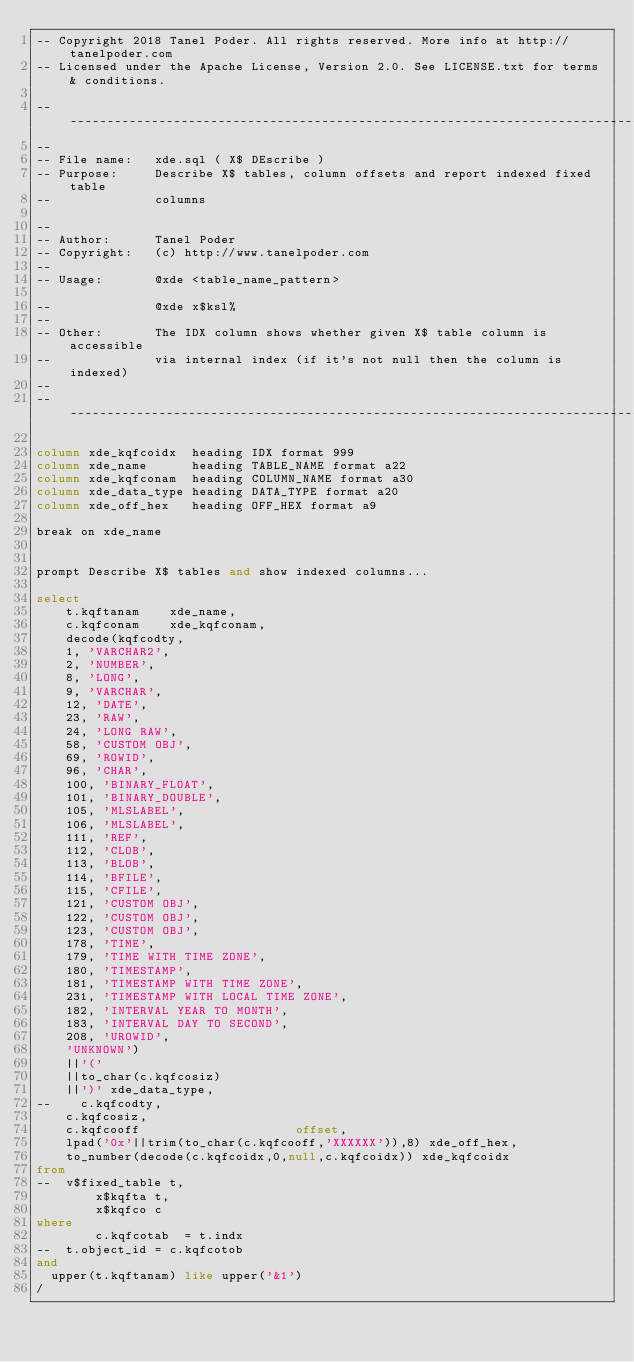<code> <loc_0><loc_0><loc_500><loc_500><_SQL_>-- Copyright 2018 Tanel Poder. All rights reserved. More info at http://tanelpoder.com
-- Licensed under the Apache License, Version 2.0. See LICENSE.txt for terms & conditions.

--------------------------------------------------------------------------------
--
-- File name:   xde.sql ( X$ DEscribe )
-- Purpose:     Describe X$ tables, column offsets and report indexed fixed table
--              columns

--              
-- Author:      Tanel Poder
-- Copyright:   (c) http://www.tanelpoder.com
--              
-- Usage:       @xde <table_name_pattern>

--              @xde x$ksl%
--
-- Other:       The IDX column shows whether given X$ table column is accessible
--              via internal index (if it's not null then the column is indexed)
--              
--------------------------------------------------------------------------------

column xde_kqfcoidx  heading IDX format 999
column xde_name      heading TABLE_NAME format a22
column xde_kqfconam  heading COLUMN_NAME format a30
column xde_data_type heading DATA_TYPE format a20
column xde_off_hex   heading OFF_HEX format a9

break on xde_name


prompt Describe X$ tables and show indexed columns...

select 
    t.kqftanam		xde_name, 
    c.kqfconam		xde_kqfconam, 
    decode(kqfcodty, 
		1, 'VARCHAR2',
		2, 'NUMBER',
		8, 'LONG',
		9, 'VARCHAR',
		12, 'DATE',
		23, 'RAW', 
		24, 'LONG RAW',
		58, 'CUSTOM OBJ',
		69, 'ROWID',
		96, 'CHAR',
		100, 'BINARY_FLOAT',
		101, 'BINARY_DOUBLE',
		105, 'MLSLABEL',
		106, 'MLSLABEL',
		111, 'REF',
		112, 'CLOB',
		113, 'BLOB', 
		114, 'BFILE', 
		115, 'CFILE',
		121, 'CUSTOM OBJ',
		122, 'CUSTOM OBJ',
		123, 'CUSTOM OBJ',
		178, 'TIME',
		179, 'TIME WITH TIME ZONE',
		180, 'TIMESTAMP',
		181, 'TIMESTAMP WITH TIME ZONE',
		231, 'TIMESTAMP WITH LOCAL TIME ZONE',
		182, 'INTERVAL YEAR TO MONTH',
		183, 'INTERVAL DAY TO SECOND',
		208, 'UROWID',
		'UNKNOWN')
		||'('
		||to_char(c.kqfcosiz)
		||')' xde_data_type,
--    c.kqfcodty,
    c.kqfcosiz, 
    c.kqfcooff                     offset, 
    lpad('0x'||trim(to_char(c.kqfcooff,'XXXXXX')),8) xde_off_hex, 
    to_number(decode(c.kqfcoidx,0,null,c.kqfcoidx)) xde_kqfcoidx
from 
--	v$fixed_table t, 
        x$kqfta t,
        x$kqfco c 
where 
        c.kqfcotab  = t.indx
--	t.object_id = c.kqfcotob 
and 
	upper(t.kqftanam) like upper('&1')
/
</code> 